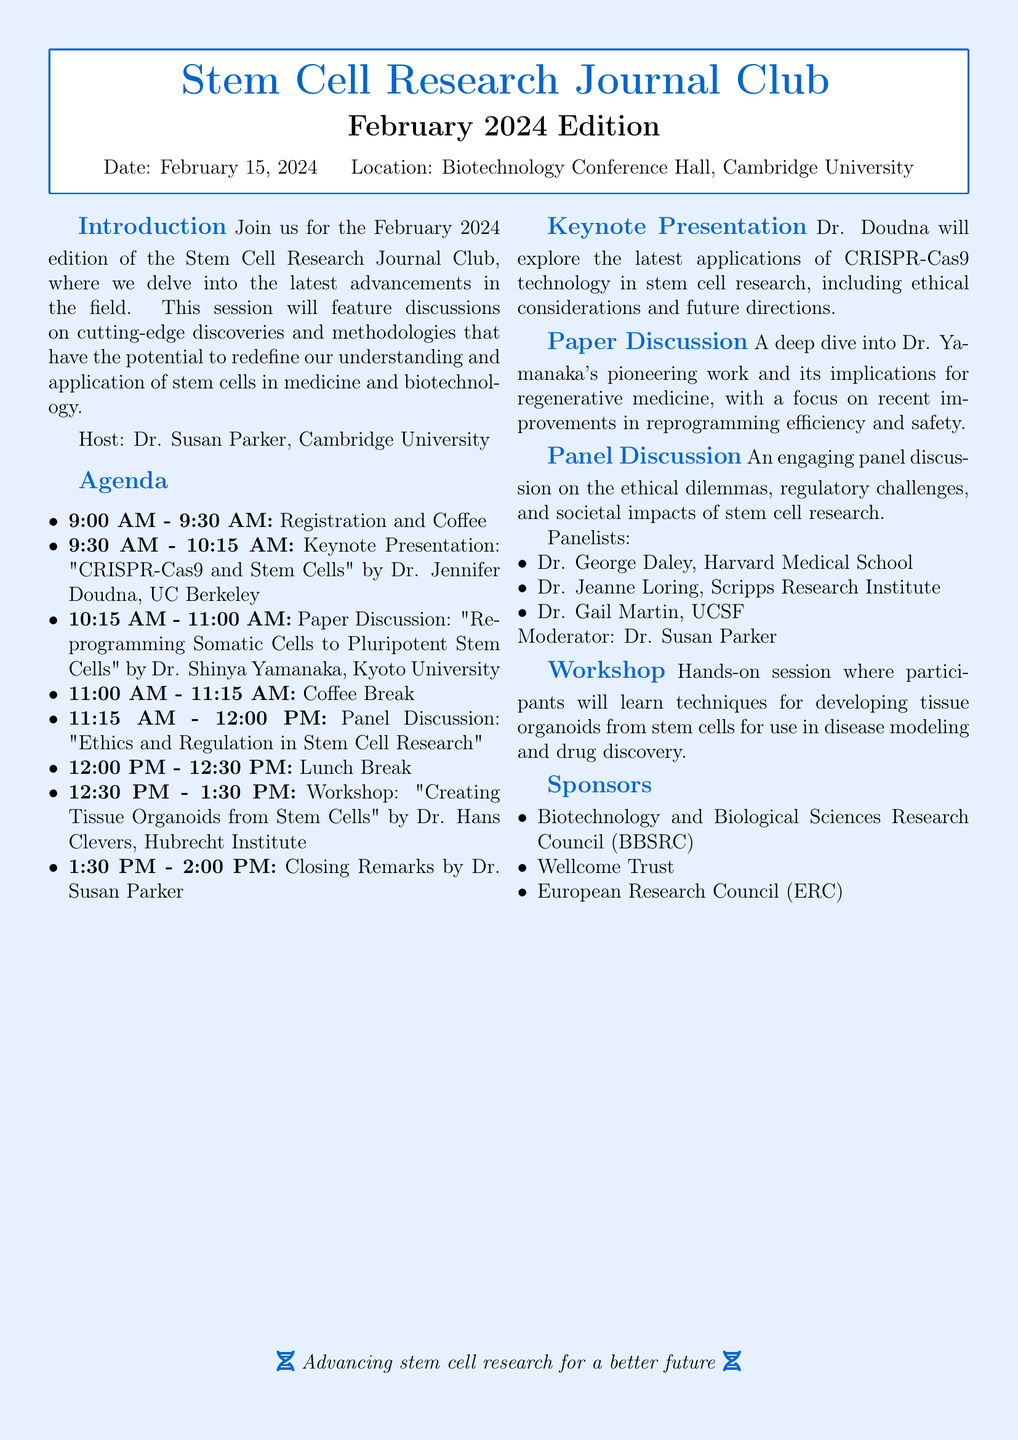What is the date of the Stem Cell Research Journal Club? The date is explicitly mentioned in the document as February 15, 2024.
Answer: February 15, 2024 Who is the host of the event? The host is identified in the introduction section as Dr. Susan Parker from Cambridge University.
Answer: Dr. Susan Parker What is the topic of the keynote presentation? The document specifies the keynote presentation topic as "CRISPR-Cas9 and Stem Cells."
Answer: CRISPR-Cas9 and Stem Cells What is the duration of the lunch break? The agenda lists the lunch break lasting from 12:00 PM to 12:30 PM, totaling 30 minutes.
Answer: 30 minutes Who are the panelists in the panel discussion? The document lists Dr. George Daley, Dr. Jeanne Loring, and Dr. Gail Martin as panelists.
Answer: Dr. George Daley, Dr. Jeanne Loring, Dr. Gail Martin What is the focus of the workshop? The workshop's focus is described as creating tissue organoids from stem cells for disease modeling and drug discovery.
Answer: Creating tissue organoids from stem cells What time does registration begin? The agenda states that registration begins at 9:00 AM.
Answer: 9:00 AM What organization is one of the sponsors? The document lists several sponsors, one of which is the Biotechnology and Biological Sciences Research Council (BBSRC).
Answer: Biotechnology and Biological Sciences Research Council (BBSRC) What is the aim of the Stem Cell Research Journal Club? The introduction mentions the aim is to delve into the latest advancements in the field of stem cell research.
Answer: Delve into the latest advancements in stem cell research 